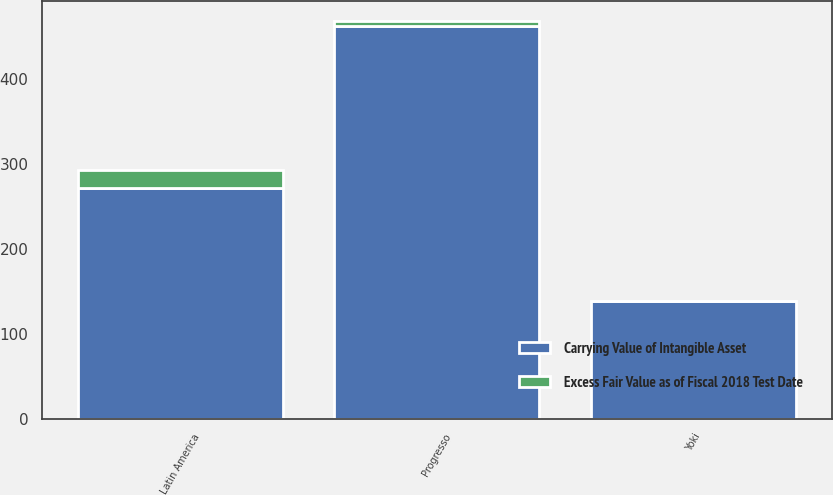<chart> <loc_0><loc_0><loc_500><loc_500><stacked_bar_chart><ecel><fcel>Yoki<fcel>Progresso<fcel>Latin America<nl><fcel>Carrying Value of Intangible Asset<fcel>138.2<fcel>462.1<fcel>272<nl><fcel>Excess Fair Value as of Fiscal 2018 Test Date<fcel>1<fcel>6<fcel>21<nl></chart> 